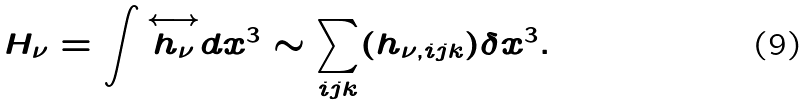Convert formula to latex. <formula><loc_0><loc_0><loc_500><loc_500>H _ { \nu } = \int { \stackrel { \longleftrightarrow } { h _ { \nu } } } d x ^ { 3 } \sim \sum _ { i j k } ( h _ { \nu , i j k } ) \delta x ^ { 3 } .</formula> 